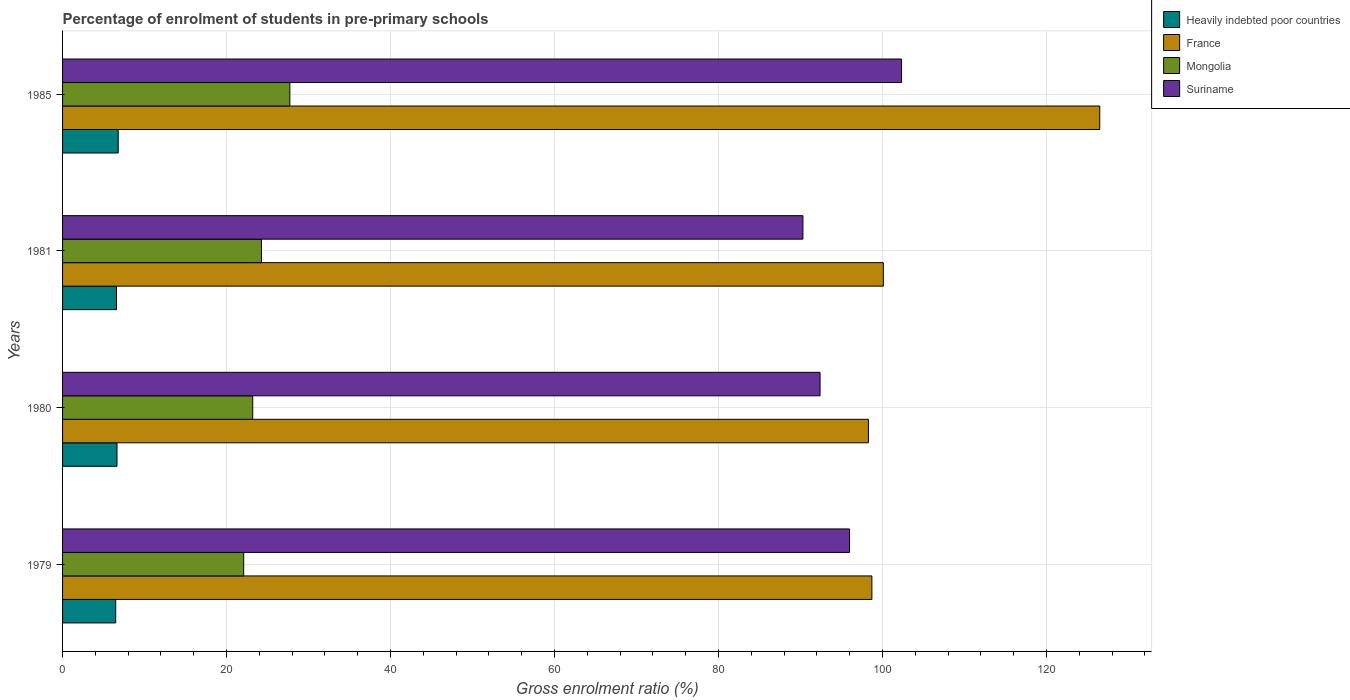How many bars are there on the 3rd tick from the top?
Offer a very short reply. 4. How many bars are there on the 1st tick from the bottom?
Make the answer very short. 4. What is the percentage of students enrolled in pre-primary schools in France in 1981?
Provide a succinct answer. 100.09. Across all years, what is the maximum percentage of students enrolled in pre-primary schools in Mongolia?
Provide a short and direct response. 27.72. Across all years, what is the minimum percentage of students enrolled in pre-primary schools in Suriname?
Your response must be concise. 90.29. In which year was the percentage of students enrolled in pre-primary schools in Mongolia minimum?
Your response must be concise. 1979. What is the total percentage of students enrolled in pre-primary schools in Mongolia in the graph?
Ensure brevity in your answer.  97.25. What is the difference between the percentage of students enrolled in pre-primary schools in Mongolia in 1979 and that in 1985?
Offer a very short reply. -5.63. What is the difference between the percentage of students enrolled in pre-primary schools in Mongolia in 1981 and the percentage of students enrolled in pre-primary schools in Suriname in 1979?
Keep it short and to the point. -71.72. What is the average percentage of students enrolled in pre-primary schools in Mongolia per year?
Make the answer very short. 24.31. In the year 1979, what is the difference between the percentage of students enrolled in pre-primary schools in Heavily indebted poor countries and percentage of students enrolled in pre-primary schools in Mongolia?
Ensure brevity in your answer.  -15.61. What is the ratio of the percentage of students enrolled in pre-primary schools in Mongolia in 1979 to that in 1985?
Offer a very short reply. 0.8. What is the difference between the highest and the second highest percentage of students enrolled in pre-primary schools in France?
Offer a very short reply. 26.39. What is the difference between the highest and the lowest percentage of students enrolled in pre-primary schools in Suriname?
Your response must be concise. 12.03. Is the sum of the percentage of students enrolled in pre-primary schools in France in 1980 and 1985 greater than the maximum percentage of students enrolled in pre-primary schools in Suriname across all years?
Your answer should be very brief. Yes. What does the 4th bar from the top in 1985 represents?
Provide a short and direct response. Heavily indebted poor countries. What does the 3rd bar from the bottom in 1979 represents?
Offer a very short reply. Mongolia. Is it the case that in every year, the sum of the percentage of students enrolled in pre-primary schools in Suriname and percentage of students enrolled in pre-primary schools in Mongolia is greater than the percentage of students enrolled in pre-primary schools in Heavily indebted poor countries?
Your answer should be compact. Yes. How many bars are there?
Offer a terse response. 16. How many years are there in the graph?
Your answer should be very brief. 4. Are the values on the major ticks of X-axis written in scientific E-notation?
Your answer should be very brief. No. Does the graph contain any zero values?
Offer a very short reply. No. Where does the legend appear in the graph?
Your response must be concise. Top right. How are the legend labels stacked?
Your response must be concise. Vertical. What is the title of the graph?
Offer a terse response. Percentage of enrolment of students in pre-primary schools. What is the Gross enrolment ratio (%) of Heavily indebted poor countries in 1979?
Provide a succinct answer. 6.48. What is the Gross enrolment ratio (%) of France in 1979?
Ensure brevity in your answer.  98.7. What is the Gross enrolment ratio (%) of Mongolia in 1979?
Offer a very short reply. 22.09. What is the Gross enrolment ratio (%) in Suriname in 1979?
Offer a very short reply. 95.97. What is the Gross enrolment ratio (%) of Heavily indebted poor countries in 1980?
Your answer should be compact. 6.64. What is the Gross enrolment ratio (%) in France in 1980?
Offer a very short reply. 98.27. What is the Gross enrolment ratio (%) in Mongolia in 1980?
Give a very brief answer. 23.19. What is the Gross enrolment ratio (%) of Suriname in 1980?
Provide a short and direct response. 92.37. What is the Gross enrolment ratio (%) in Heavily indebted poor countries in 1981?
Your response must be concise. 6.58. What is the Gross enrolment ratio (%) in France in 1981?
Your response must be concise. 100.09. What is the Gross enrolment ratio (%) of Mongolia in 1981?
Your answer should be compact. 24.25. What is the Gross enrolment ratio (%) of Suriname in 1981?
Make the answer very short. 90.29. What is the Gross enrolment ratio (%) of Heavily indebted poor countries in 1985?
Ensure brevity in your answer.  6.79. What is the Gross enrolment ratio (%) in France in 1985?
Keep it short and to the point. 126.48. What is the Gross enrolment ratio (%) of Mongolia in 1985?
Offer a very short reply. 27.72. What is the Gross enrolment ratio (%) in Suriname in 1985?
Keep it short and to the point. 102.31. Across all years, what is the maximum Gross enrolment ratio (%) of Heavily indebted poor countries?
Give a very brief answer. 6.79. Across all years, what is the maximum Gross enrolment ratio (%) of France?
Make the answer very short. 126.48. Across all years, what is the maximum Gross enrolment ratio (%) in Mongolia?
Provide a succinct answer. 27.72. Across all years, what is the maximum Gross enrolment ratio (%) in Suriname?
Offer a very short reply. 102.31. Across all years, what is the minimum Gross enrolment ratio (%) in Heavily indebted poor countries?
Make the answer very short. 6.48. Across all years, what is the minimum Gross enrolment ratio (%) of France?
Offer a very short reply. 98.27. Across all years, what is the minimum Gross enrolment ratio (%) in Mongolia?
Your answer should be compact. 22.09. Across all years, what is the minimum Gross enrolment ratio (%) in Suriname?
Offer a very short reply. 90.29. What is the total Gross enrolment ratio (%) in Heavily indebted poor countries in the graph?
Offer a terse response. 26.48. What is the total Gross enrolment ratio (%) of France in the graph?
Your response must be concise. 423.54. What is the total Gross enrolment ratio (%) of Mongolia in the graph?
Your answer should be very brief. 97.25. What is the total Gross enrolment ratio (%) in Suriname in the graph?
Provide a short and direct response. 380.95. What is the difference between the Gross enrolment ratio (%) in Heavily indebted poor countries in 1979 and that in 1980?
Offer a terse response. -0.16. What is the difference between the Gross enrolment ratio (%) of France in 1979 and that in 1980?
Provide a short and direct response. 0.42. What is the difference between the Gross enrolment ratio (%) of Mongolia in 1979 and that in 1980?
Keep it short and to the point. -1.1. What is the difference between the Gross enrolment ratio (%) of Suriname in 1979 and that in 1980?
Offer a very short reply. 3.6. What is the difference between the Gross enrolment ratio (%) in Heavily indebted poor countries in 1979 and that in 1981?
Give a very brief answer. -0.1. What is the difference between the Gross enrolment ratio (%) of France in 1979 and that in 1981?
Ensure brevity in your answer.  -1.4. What is the difference between the Gross enrolment ratio (%) of Mongolia in 1979 and that in 1981?
Your response must be concise. -2.16. What is the difference between the Gross enrolment ratio (%) of Suriname in 1979 and that in 1981?
Ensure brevity in your answer.  5.69. What is the difference between the Gross enrolment ratio (%) in Heavily indebted poor countries in 1979 and that in 1985?
Offer a very short reply. -0.31. What is the difference between the Gross enrolment ratio (%) of France in 1979 and that in 1985?
Make the answer very short. -27.79. What is the difference between the Gross enrolment ratio (%) of Mongolia in 1979 and that in 1985?
Offer a terse response. -5.63. What is the difference between the Gross enrolment ratio (%) in Suriname in 1979 and that in 1985?
Provide a short and direct response. -6.34. What is the difference between the Gross enrolment ratio (%) of Heavily indebted poor countries in 1980 and that in 1981?
Ensure brevity in your answer.  0.06. What is the difference between the Gross enrolment ratio (%) in France in 1980 and that in 1981?
Provide a short and direct response. -1.82. What is the difference between the Gross enrolment ratio (%) of Mongolia in 1980 and that in 1981?
Your response must be concise. -1.06. What is the difference between the Gross enrolment ratio (%) in Suriname in 1980 and that in 1981?
Give a very brief answer. 2.09. What is the difference between the Gross enrolment ratio (%) in Heavily indebted poor countries in 1980 and that in 1985?
Your answer should be compact. -0.15. What is the difference between the Gross enrolment ratio (%) of France in 1980 and that in 1985?
Provide a succinct answer. -28.21. What is the difference between the Gross enrolment ratio (%) in Mongolia in 1980 and that in 1985?
Your answer should be very brief. -4.53. What is the difference between the Gross enrolment ratio (%) of Suriname in 1980 and that in 1985?
Your answer should be compact. -9.94. What is the difference between the Gross enrolment ratio (%) of Heavily indebted poor countries in 1981 and that in 1985?
Offer a terse response. -0.21. What is the difference between the Gross enrolment ratio (%) of France in 1981 and that in 1985?
Keep it short and to the point. -26.39. What is the difference between the Gross enrolment ratio (%) in Mongolia in 1981 and that in 1985?
Your answer should be very brief. -3.47. What is the difference between the Gross enrolment ratio (%) in Suriname in 1981 and that in 1985?
Give a very brief answer. -12.03. What is the difference between the Gross enrolment ratio (%) in Heavily indebted poor countries in 1979 and the Gross enrolment ratio (%) in France in 1980?
Offer a terse response. -91.79. What is the difference between the Gross enrolment ratio (%) of Heavily indebted poor countries in 1979 and the Gross enrolment ratio (%) of Mongolia in 1980?
Make the answer very short. -16.71. What is the difference between the Gross enrolment ratio (%) of Heavily indebted poor countries in 1979 and the Gross enrolment ratio (%) of Suriname in 1980?
Provide a succinct answer. -85.89. What is the difference between the Gross enrolment ratio (%) of France in 1979 and the Gross enrolment ratio (%) of Mongolia in 1980?
Keep it short and to the point. 75.5. What is the difference between the Gross enrolment ratio (%) in France in 1979 and the Gross enrolment ratio (%) in Suriname in 1980?
Give a very brief answer. 6.32. What is the difference between the Gross enrolment ratio (%) of Mongolia in 1979 and the Gross enrolment ratio (%) of Suriname in 1980?
Offer a terse response. -70.28. What is the difference between the Gross enrolment ratio (%) of Heavily indebted poor countries in 1979 and the Gross enrolment ratio (%) of France in 1981?
Offer a terse response. -93.61. What is the difference between the Gross enrolment ratio (%) in Heavily indebted poor countries in 1979 and the Gross enrolment ratio (%) in Mongolia in 1981?
Keep it short and to the point. -17.77. What is the difference between the Gross enrolment ratio (%) of Heavily indebted poor countries in 1979 and the Gross enrolment ratio (%) of Suriname in 1981?
Your response must be concise. -83.81. What is the difference between the Gross enrolment ratio (%) in France in 1979 and the Gross enrolment ratio (%) in Mongolia in 1981?
Your answer should be very brief. 74.44. What is the difference between the Gross enrolment ratio (%) of France in 1979 and the Gross enrolment ratio (%) of Suriname in 1981?
Your response must be concise. 8.41. What is the difference between the Gross enrolment ratio (%) in Mongolia in 1979 and the Gross enrolment ratio (%) in Suriname in 1981?
Your answer should be very brief. -68.2. What is the difference between the Gross enrolment ratio (%) in Heavily indebted poor countries in 1979 and the Gross enrolment ratio (%) in France in 1985?
Ensure brevity in your answer.  -120. What is the difference between the Gross enrolment ratio (%) in Heavily indebted poor countries in 1979 and the Gross enrolment ratio (%) in Mongolia in 1985?
Your answer should be compact. -21.24. What is the difference between the Gross enrolment ratio (%) in Heavily indebted poor countries in 1979 and the Gross enrolment ratio (%) in Suriname in 1985?
Offer a terse response. -95.83. What is the difference between the Gross enrolment ratio (%) of France in 1979 and the Gross enrolment ratio (%) of Mongolia in 1985?
Give a very brief answer. 70.98. What is the difference between the Gross enrolment ratio (%) in France in 1979 and the Gross enrolment ratio (%) in Suriname in 1985?
Provide a succinct answer. -3.62. What is the difference between the Gross enrolment ratio (%) in Mongolia in 1979 and the Gross enrolment ratio (%) in Suriname in 1985?
Provide a short and direct response. -80.23. What is the difference between the Gross enrolment ratio (%) in Heavily indebted poor countries in 1980 and the Gross enrolment ratio (%) in France in 1981?
Offer a very short reply. -93.45. What is the difference between the Gross enrolment ratio (%) in Heavily indebted poor countries in 1980 and the Gross enrolment ratio (%) in Mongolia in 1981?
Offer a terse response. -17.61. What is the difference between the Gross enrolment ratio (%) in Heavily indebted poor countries in 1980 and the Gross enrolment ratio (%) in Suriname in 1981?
Ensure brevity in your answer.  -83.65. What is the difference between the Gross enrolment ratio (%) in France in 1980 and the Gross enrolment ratio (%) in Mongolia in 1981?
Offer a very short reply. 74.02. What is the difference between the Gross enrolment ratio (%) in France in 1980 and the Gross enrolment ratio (%) in Suriname in 1981?
Offer a terse response. 7.99. What is the difference between the Gross enrolment ratio (%) in Mongolia in 1980 and the Gross enrolment ratio (%) in Suriname in 1981?
Your response must be concise. -67.09. What is the difference between the Gross enrolment ratio (%) of Heavily indebted poor countries in 1980 and the Gross enrolment ratio (%) of France in 1985?
Provide a succinct answer. -119.85. What is the difference between the Gross enrolment ratio (%) in Heavily indebted poor countries in 1980 and the Gross enrolment ratio (%) in Mongolia in 1985?
Offer a terse response. -21.08. What is the difference between the Gross enrolment ratio (%) in Heavily indebted poor countries in 1980 and the Gross enrolment ratio (%) in Suriname in 1985?
Ensure brevity in your answer.  -95.68. What is the difference between the Gross enrolment ratio (%) in France in 1980 and the Gross enrolment ratio (%) in Mongolia in 1985?
Give a very brief answer. 70.55. What is the difference between the Gross enrolment ratio (%) in France in 1980 and the Gross enrolment ratio (%) in Suriname in 1985?
Your answer should be compact. -4.04. What is the difference between the Gross enrolment ratio (%) of Mongolia in 1980 and the Gross enrolment ratio (%) of Suriname in 1985?
Give a very brief answer. -79.12. What is the difference between the Gross enrolment ratio (%) in Heavily indebted poor countries in 1981 and the Gross enrolment ratio (%) in France in 1985?
Offer a very short reply. -119.91. What is the difference between the Gross enrolment ratio (%) of Heavily indebted poor countries in 1981 and the Gross enrolment ratio (%) of Mongolia in 1985?
Provide a short and direct response. -21.14. What is the difference between the Gross enrolment ratio (%) of Heavily indebted poor countries in 1981 and the Gross enrolment ratio (%) of Suriname in 1985?
Give a very brief answer. -95.74. What is the difference between the Gross enrolment ratio (%) of France in 1981 and the Gross enrolment ratio (%) of Mongolia in 1985?
Provide a short and direct response. 72.37. What is the difference between the Gross enrolment ratio (%) in France in 1981 and the Gross enrolment ratio (%) in Suriname in 1985?
Keep it short and to the point. -2.22. What is the difference between the Gross enrolment ratio (%) of Mongolia in 1981 and the Gross enrolment ratio (%) of Suriname in 1985?
Ensure brevity in your answer.  -78.06. What is the average Gross enrolment ratio (%) of Heavily indebted poor countries per year?
Your response must be concise. 6.62. What is the average Gross enrolment ratio (%) in France per year?
Provide a short and direct response. 105.89. What is the average Gross enrolment ratio (%) of Mongolia per year?
Provide a short and direct response. 24.31. What is the average Gross enrolment ratio (%) of Suriname per year?
Offer a very short reply. 95.24. In the year 1979, what is the difference between the Gross enrolment ratio (%) in Heavily indebted poor countries and Gross enrolment ratio (%) in France?
Ensure brevity in your answer.  -92.22. In the year 1979, what is the difference between the Gross enrolment ratio (%) in Heavily indebted poor countries and Gross enrolment ratio (%) in Mongolia?
Offer a terse response. -15.61. In the year 1979, what is the difference between the Gross enrolment ratio (%) in Heavily indebted poor countries and Gross enrolment ratio (%) in Suriname?
Provide a short and direct response. -89.49. In the year 1979, what is the difference between the Gross enrolment ratio (%) in France and Gross enrolment ratio (%) in Mongolia?
Keep it short and to the point. 76.61. In the year 1979, what is the difference between the Gross enrolment ratio (%) of France and Gross enrolment ratio (%) of Suriname?
Keep it short and to the point. 2.72. In the year 1979, what is the difference between the Gross enrolment ratio (%) in Mongolia and Gross enrolment ratio (%) in Suriname?
Your response must be concise. -73.88. In the year 1980, what is the difference between the Gross enrolment ratio (%) in Heavily indebted poor countries and Gross enrolment ratio (%) in France?
Keep it short and to the point. -91.63. In the year 1980, what is the difference between the Gross enrolment ratio (%) in Heavily indebted poor countries and Gross enrolment ratio (%) in Mongolia?
Keep it short and to the point. -16.55. In the year 1980, what is the difference between the Gross enrolment ratio (%) in Heavily indebted poor countries and Gross enrolment ratio (%) in Suriname?
Make the answer very short. -85.73. In the year 1980, what is the difference between the Gross enrolment ratio (%) in France and Gross enrolment ratio (%) in Mongolia?
Your answer should be very brief. 75.08. In the year 1980, what is the difference between the Gross enrolment ratio (%) of France and Gross enrolment ratio (%) of Suriname?
Your response must be concise. 5.9. In the year 1980, what is the difference between the Gross enrolment ratio (%) of Mongolia and Gross enrolment ratio (%) of Suriname?
Your answer should be very brief. -69.18. In the year 1981, what is the difference between the Gross enrolment ratio (%) in Heavily indebted poor countries and Gross enrolment ratio (%) in France?
Make the answer very short. -93.52. In the year 1981, what is the difference between the Gross enrolment ratio (%) of Heavily indebted poor countries and Gross enrolment ratio (%) of Mongolia?
Offer a very short reply. -17.68. In the year 1981, what is the difference between the Gross enrolment ratio (%) in Heavily indebted poor countries and Gross enrolment ratio (%) in Suriname?
Your answer should be very brief. -83.71. In the year 1981, what is the difference between the Gross enrolment ratio (%) in France and Gross enrolment ratio (%) in Mongolia?
Your answer should be very brief. 75.84. In the year 1981, what is the difference between the Gross enrolment ratio (%) in France and Gross enrolment ratio (%) in Suriname?
Keep it short and to the point. 9.81. In the year 1981, what is the difference between the Gross enrolment ratio (%) of Mongolia and Gross enrolment ratio (%) of Suriname?
Offer a very short reply. -66.03. In the year 1985, what is the difference between the Gross enrolment ratio (%) in Heavily indebted poor countries and Gross enrolment ratio (%) in France?
Offer a terse response. -119.69. In the year 1985, what is the difference between the Gross enrolment ratio (%) in Heavily indebted poor countries and Gross enrolment ratio (%) in Mongolia?
Offer a very short reply. -20.93. In the year 1985, what is the difference between the Gross enrolment ratio (%) of Heavily indebted poor countries and Gross enrolment ratio (%) of Suriname?
Offer a terse response. -95.52. In the year 1985, what is the difference between the Gross enrolment ratio (%) of France and Gross enrolment ratio (%) of Mongolia?
Keep it short and to the point. 98.77. In the year 1985, what is the difference between the Gross enrolment ratio (%) of France and Gross enrolment ratio (%) of Suriname?
Provide a succinct answer. 24.17. In the year 1985, what is the difference between the Gross enrolment ratio (%) of Mongolia and Gross enrolment ratio (%) of Suriname?
Provide a short and direct response. -74.6. What is the ratio of the Gross enrolment ratio (%) in Heavily indebted poor countries in 1979 to that in 1980?
Offer a very short reply. 0.98. What is the ratio of the Gross enrolment ratio (%) in Mongolia in 1979 to that in 1980?
Your answer should be very brief. 0.95. What is the ratio of the Gross enrolment ratio (%) of Suriname in 1979 to that in 1980?
Provide a succinct answer. 1.04. What is the ratio of the Gross enrolment ratio (%) of Heavily indebted poor countries in 1979 to that in 1981?
Offer a terse response. 0.99. What is the ratio of the Gross enrolment ratio (%) of France in 1979 to that in 1981?
Provide a short and direct response. 0.99. What is the ratio of the Gross enrolment ratio (%) in Mongolia in 1979 to that in 1981?
Your response must be concise. 0.91. What is the ratio of the Gross enrolment ratio (%) of Suriname in 1979 to that in 1981?
Your answer should be compact. 1.06. What is the ratio of the Gross enrolment ratio (%) in Heavily indebted poor countries in 1979 to that in 1985?
Provide a succinct answer. 0.95. What is the ratio of the Gross enrolment ratio (%) of France in 1979 to that in 1985?
Offer a terse response. 0.78. What is the ratio of the Gross enrolment ratio (%) of Mongolia in 1979 to that in 1985?
Offer a terse response. 0.8. What is the ratio of the Gross enrolment ratio (%) of Suriname in 1979 to that in 1985?
Your answer should be very brief. 0.94. What is the ratio of the Gross enrolment ratio (%) in Heavily indebted poor countries in 1980 to that in 1981?
Your answer should be compact. 1.01. What is the ratio of the Gross enrolment ratio (%) of France in 1980 to that in 1981?
Give a very brief answer. 0.98. What is the ratio of the Gross enrolment ratio (%) of Mongolia in 1980 to that in 1981?
Give a very brief answer. 0.96. What is the ratio of the Gross enrolment ratio (%) in Suriname in 1980 to that in 1981?
Your answer should be compact. 1.02. What is the ratio of the Gross enrolment ratio (%) of Heavily indebted poor countries in 1980 to that in 1985?
Give a very brief answer. 0.98. What is the ratio of the Gross enrolment ratio (%) of France in 1980 to that in 1985?
Offer a terse response. 0.78. What is the ratio of the Gross enrolment ratio (%) of Mongolia in 1980 to that in 1985?
Ensure brevity in your answer.  0.84. What is the ratio of the Gross enrolment ratio (%) in Suriname in 1980 to that in 1985?
Provide a short and direct response. 0.9. What is the ratio of the Gross enrolment ratio (%) in Heavily indebted poor countries in 1981 to that in 1985?
Provide a succinct answer. 0.97. What is the ratio of the Gross enrolment ratio (%) in France in 1981 to that in 1985?
Ensure brevity in your answer.  0.79. What is the ratio of the Gross enrolment ratio (%) in Mongolia in 1981 to that in 1985?
Give a very brief answer. 0.87. What is the ratio of the Gross enrolment ratio (%) in Suriname in 1981 to that in 1985?
Provide a succinct answer. 0.88. What is the difference between the highest and the second highest Gross enrolment ratio (%) in Heavily indebted poor countries?
Offer a terse response. 0.15. What is the difference between the highest and the second highest Gross enrolment ratio (%) of France?
Offer a very short reply. 26.39. What is the difference between the highest and the second highest Gross enrolment ratio (%) in Mongolia?
Provide a short and direct response. 3.47. What is the difference between the highest and the second highest Gross enrolment ratio (%) in Suriname?
Give a very brief answer. 6.34. What is the difference between the highest and the lowest Gross enrolment ratio (%) in Heavily indebted poor countries?
Ensure brevity in your answer.  0.31. What is the difference between the highest and the lowest Gross enrolment ratio (%) in France?
Ensure brevity in your answer.  28.21. What is the difference between the highest and the lowest Gross enrolment ratio (%) in Mongolia?
Provide a succinct answer. 5.63. What is the difference between the highest and the lowest Gross enrolment ratio (%) of Suriname?
Your answer should be very brief. 12.03. 